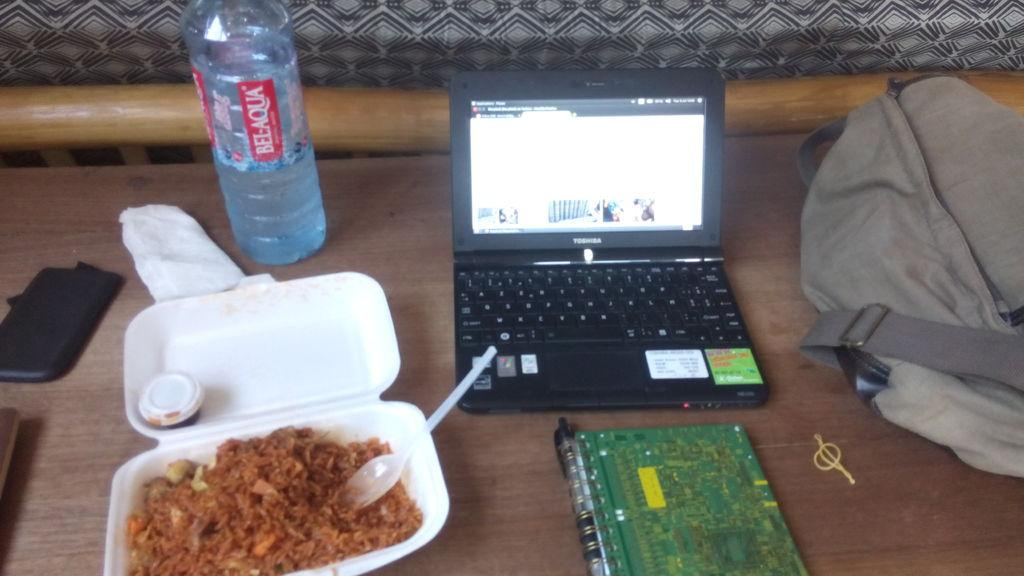<image>
Describe the image concisely. a desk with a meal and bottle of bel-aqua water on it. 